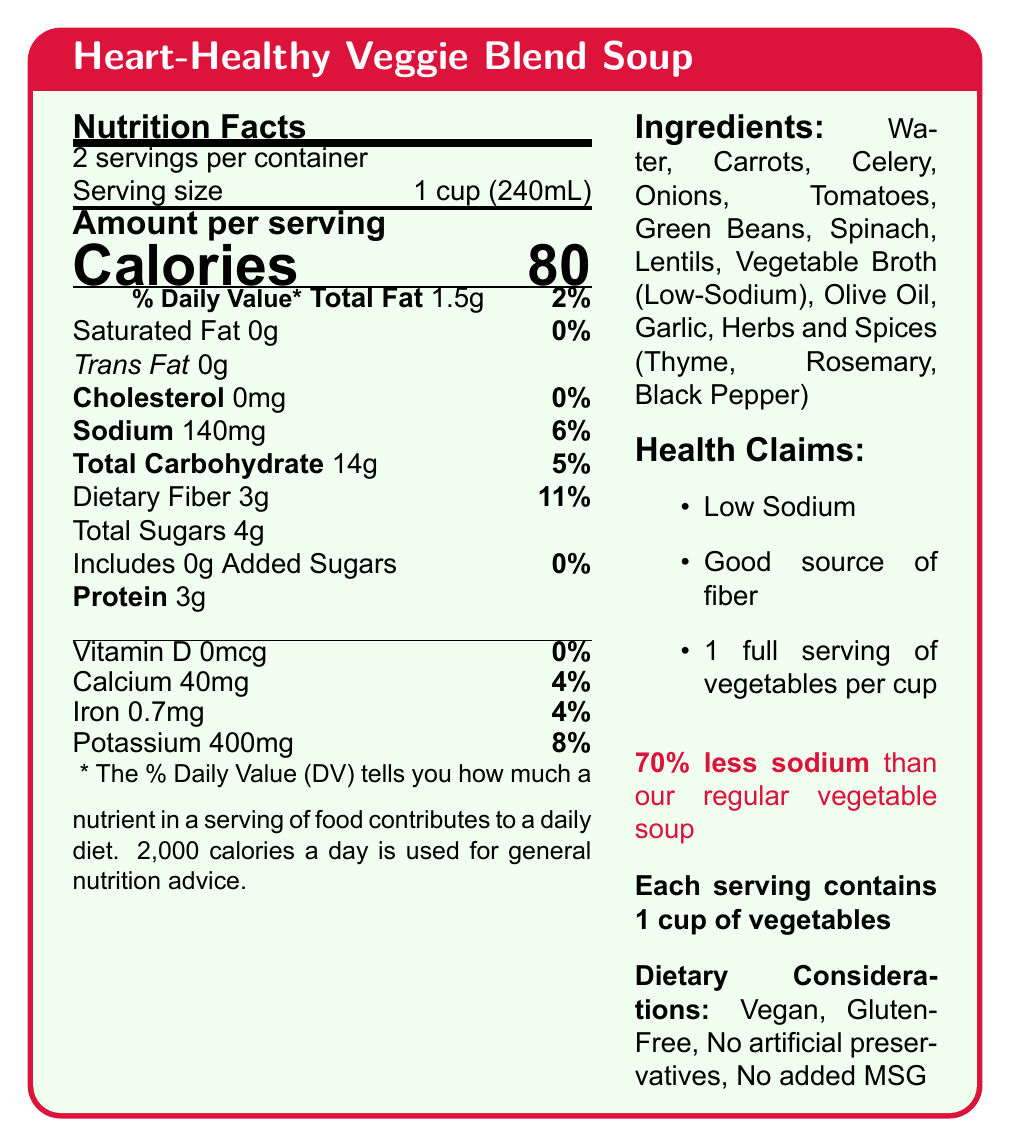what is the serving size of the Heart-Healthy Veggie Blend Soup? The serving size is stated as "1 cup (240mL)" in the document.
Answer: 1 cup (240mL) what percentage of the daily value (DV) for sodium does one serving of the soup provide? The percentage of the daily value for sodium is listed as 6% per serving in the document.
Answer: 6% how much dietary fiber is in one serving of the soup? The document lists the dietary fiber content as "3g" per serving.
Answer: 3g what is the special statement mentioned about sodium in the soup? The document has a statement: "70% less sodium than our regular vegetable soup".
Answer: 70% less sodium than our regular vegetable soup does the soup contain any trans fat? The document specifies that the amount of trans fat is "0g".
Answer: No how many servings of vegetables are in one cup of the soup? The health claims section mentions "1 full serving of vegetables per cup".
Answer: 1 full serving of vegetables per cup which vitamin is not present in the soup? A. Vitamin D B. Vitamin C C. Vitamin A D. Vitamin E According to the document, Vitamin D is listed as "0mcg" with a %DV of 0%.
Answer: A. Vitamin D what are some dietary considerations mentioned for the soup? A. Vegan B. Gluten-Free C. Contains artificial preservatives D. No added MSG The dietary considerations are listed as Vegan, Gluten-Free, No artificial preservatives, and No added MSG; the correct option is "No added MSG".
Answer: D. No added MSG is the soup a good source of fiber? One of the health claims is "Good source of fiber".
Answer: Yes how much potassium is in one serving of the soup? The amount of potassium per serving is listed as "400 mg", which is 8% of the daily value.
Answer: 400mg summarize the main points of the Heart-Healthy Veggie Blend Soup nutrition facts label. The document combines various elements such as nutrition facts, health claims, ingredients, and dietary considerations, emphasizing the low-sodium content and benefits of vegetable servings for heart health.
Answer: The Heart-Healthy Veggie Blend Soup is designed with health in mind, offering 80 calories per 1-cup serving, low sodium at 140mg per serving, and good sources of fiber and potassium, with 3g and 400mg respectively. It contains no saturated fats or cholesterol and is enriched with a variety of vegetables. Additionally, the soup is vegan, gluten-free, has no artificial preservatives, and no added MSG, aiming to support heart health with a 70% reduction in sodium compared to regular vegetable soup. It includes 1 full serving of vegetables per cup. what is the sodium content of the soup in mg? The document lists the sodium content as "140mg" per serving.
Answer: 140mg what health benefits does fiber provide according to this document? The health educator notes mention that fiber contributes to digestive health and feeling full.
Answer: Contributes to digestive health and feeling full can we determine the amount of Vitamin C in the soup from the document? The document does not provide any details about the presence or amount of Vitamin C.
Answer: Not enough information is this soup considered low-sodium? One of the health claims specifically states that the soup is "Low Sodium".
Answer: Yes 